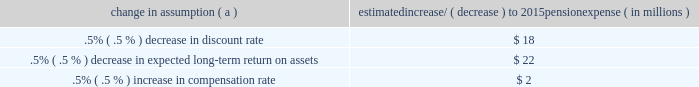The discount rate used to measure pension obligations is determined by comparing the expected future benefits that will be paid under the plan with yields available on high quality corporate bonds of similar duration .
The impact on pension expense of a .5% ( .5 % ) decrease in discount rate in the current environment is an increase of $ 18 million per year .
This sensitivity depends on the economic environment and amount of unrecognized actuarial gains or losses on the measurement date .
The expected long-term return on assets assumption also has a significant effect on pension expense .
The expected return on plan assets is a long-term assumption established by considering historical and anticipated returns of the asset classes invested in by the pension plan and the asset allocation policy currently in place .
For purposes of setting and reviewing this assumption , 201clong term 201d refers to the period over which the plan 2019s projected benefit obligations will be disbursed .
We review this assumption at each measurement date and adjust it if warranted .
Our selection process references certain historical data and the current environment , but primarily utilizes qualitative judgment regarding future return expectations .
To evaluate the continued reasonableness of our assumption , we examine a variety of viewpoints and data .
Various studies have shown that portfolios comprised primarily of u.s .
Equity securities have historically returned approximately 9% ( 9 % ) annually over long periods of time , while u.s .
Debt securities have returned approximately 6% ( 6 % ) annually over long periods .
Application of these historical returns to the plan 2019s allocation ranges for equities and bonds produces a result between 6.50% ( 6.50 % ) and 7.25% ( 7.25 % ) and is one point of reference , among many other factors , that is taken into consideration .
We also examine the plan 2019s actual historical returns over various periods and consider the current economic environment .
Recent experience is considered in our evaluation with appropriate consideration that , especially for short time periods , recent returns are not reliable indicators of future returns .
While annual returns can vary significantly ( actual returns for 2014 , 2013 and 2012 were +6.50% ( +6.50 % ) , +15.48% ( +15.48 % ) , and +15.29% ( +15.29 % ) , respectively ) , the selected assumption represents our estimated long-term average prospective returns .
Acknowledging the potentially wide range for this assumption , we also annually examine the assumption used by other companies with similar pension investment strategies , so that we can ascertain whether our determinations markedly differ from others .
In all cases , however , this data simply informs our process , which places the greatest emphasis on our qualitative judgment of future investment returns , given the conditions existing at each annual measurement date .
Taking into consideration all of these factors , the expected long-term return on plan assets for determining net periodic pension cost for 2014 was 7.00% ( 7.00 % ) , down from 7.50% ( 7.50 % ) for 2013 .
After considering the views of both internal and external capital market advisors , particularly with regard to the effects of the recent economic environment on long-term prospective fixed income returns , we are reducing our expected long-term return on assets to 6.75% ( 6.75 % ) for determining pension cost for under current accounting rules , the difference between expected long-term returns and actual returns is accumulated and amortized to pension expense over future periods .
Each one percentage point difference in actual return compared with our expected return can cause expense in subsequent years to increase or decrease by up to $ 9 million as the impact is amortized into results of operations .
We currently estimate pretax pension expense of $ 9 million in 2015 compared with pretax income of $ 7 million in 2014 .
This year-over-year expected increase in expense reflects the effects of the lower expected return on asset assumption , improved mortality , and the lower discount rate required to be used in 2015 .
These factors will be partially offset by the favorable impact of the increase in plan assets at december 31 , 2014 and the assumed return on a $ 200 million voluntary contribution to the plan made in february 2015 .
The table below reflects the estimated effects on pension expense of certain changes in annual assumptions , using 2015 estimated expense as a baseline .
Table 26 : pension expense 2013 sensitivity analysis change in assumption ( a ) estimated increase/ ( decrease ) to 2015 pension expense ( in millions ) .
( a ) the impact is the effect of changing the specified assumption while holding all other assumptions constant .
Our pension plan contribution requirements are not particularly sensitive to actuarial assumptions .
Investment performance has the most impact on contribution requirements and will drive the amount of required contributions in future years .
Also , current law , including the provisions of the pension protection act of 2006 , sets limits as to both minimum and maximum contributions to the plan .
Notwithstanding the voluntary contribution made in february 2015 noted above , we do not expect to be required to make any contributions to the plan during 2015 .
We maintain other defined benefit plans that have a less significant effect on financial results , including various nonqualified supplemental retirement plans for certain employees , which are described more fully in note 13 employee benefit plans in the notes to consolidated financial statements in item 8 of this report .
66 the pnc financial services group , inc .
2013 form 10-k .
What's the percentage increase from the 2014 estimated pretax pension expense with the expense for 2015? 
Computations: (((9 - 7) / 7) * 100)
Answer: 28.57143. 